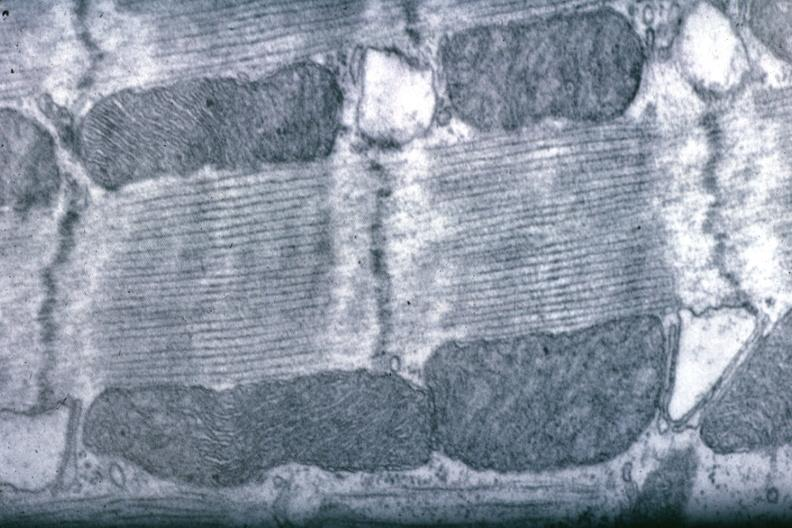s cardiovascular present?
Answer the question using a single word or phrase. Yes 